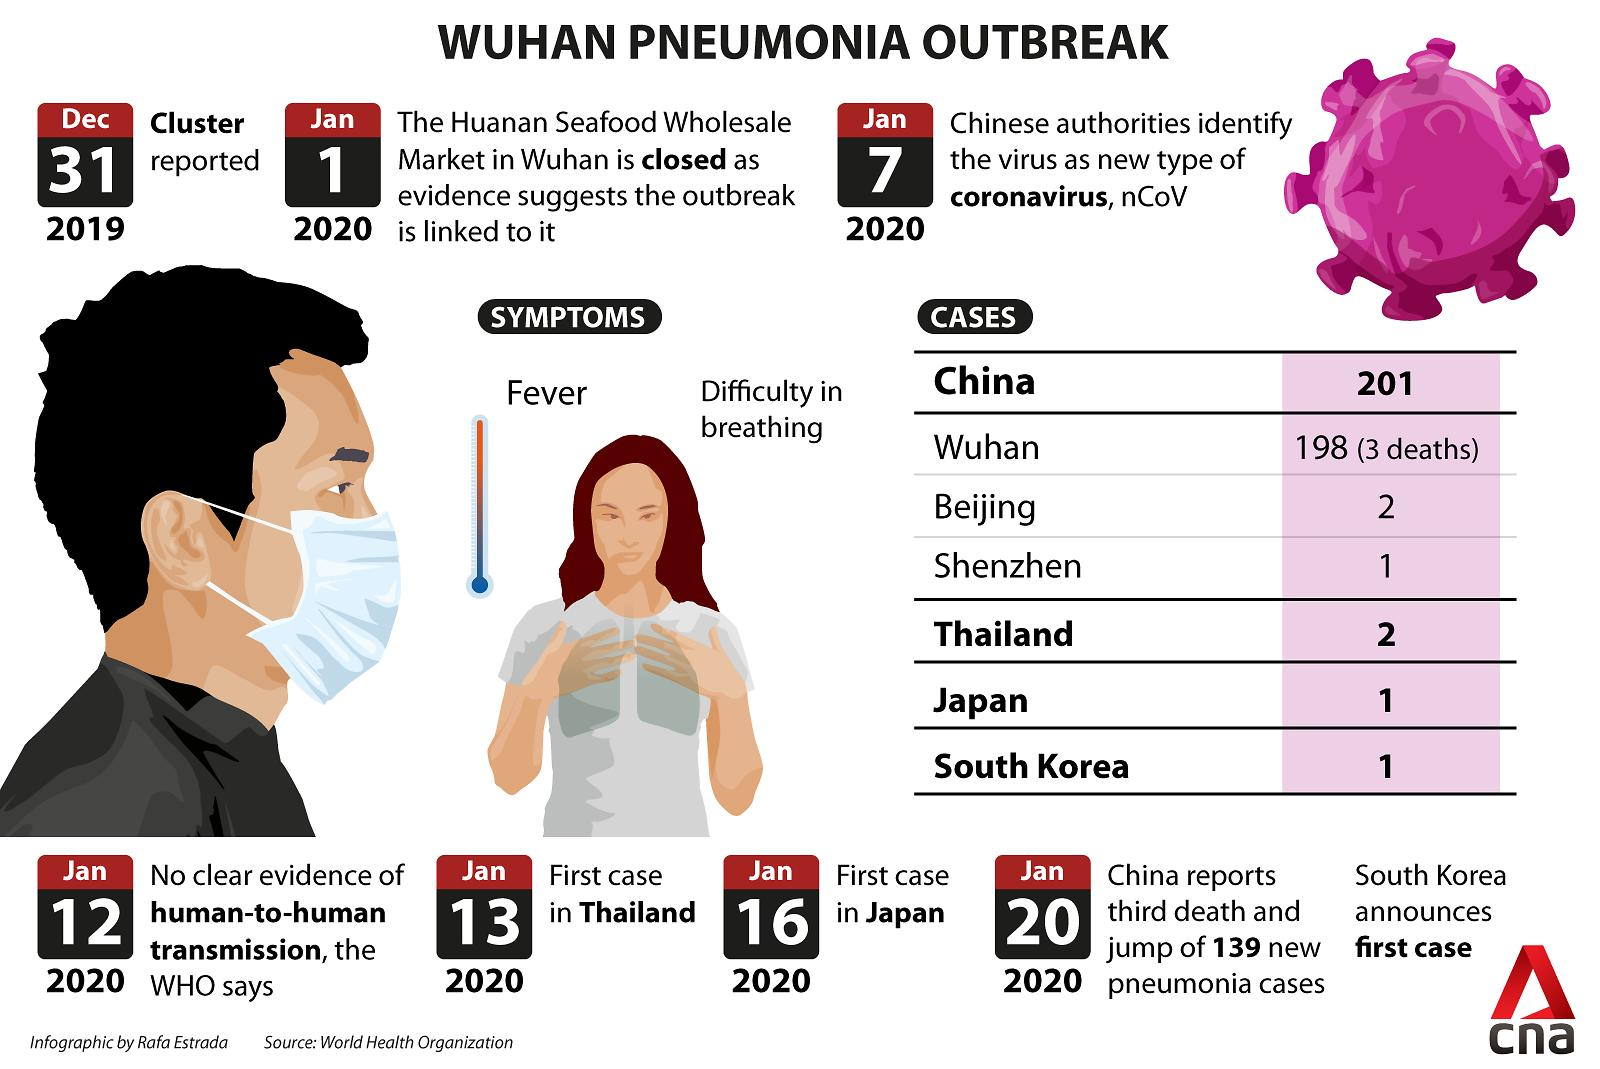Give some essential details in this illustration. There were 3 reported deaths from pneumonia in Wuhan in January 2020. On January 20, 2020, the first case of coronavirus was detected in South Korea. On January 16, 2020, the first case of coronavirus was detected in Japan. Pneumonia is characterized by symptoms such as fever and difficulty in breathing. As of January 2020, there were 201 reported cases of coronavirus in China. 